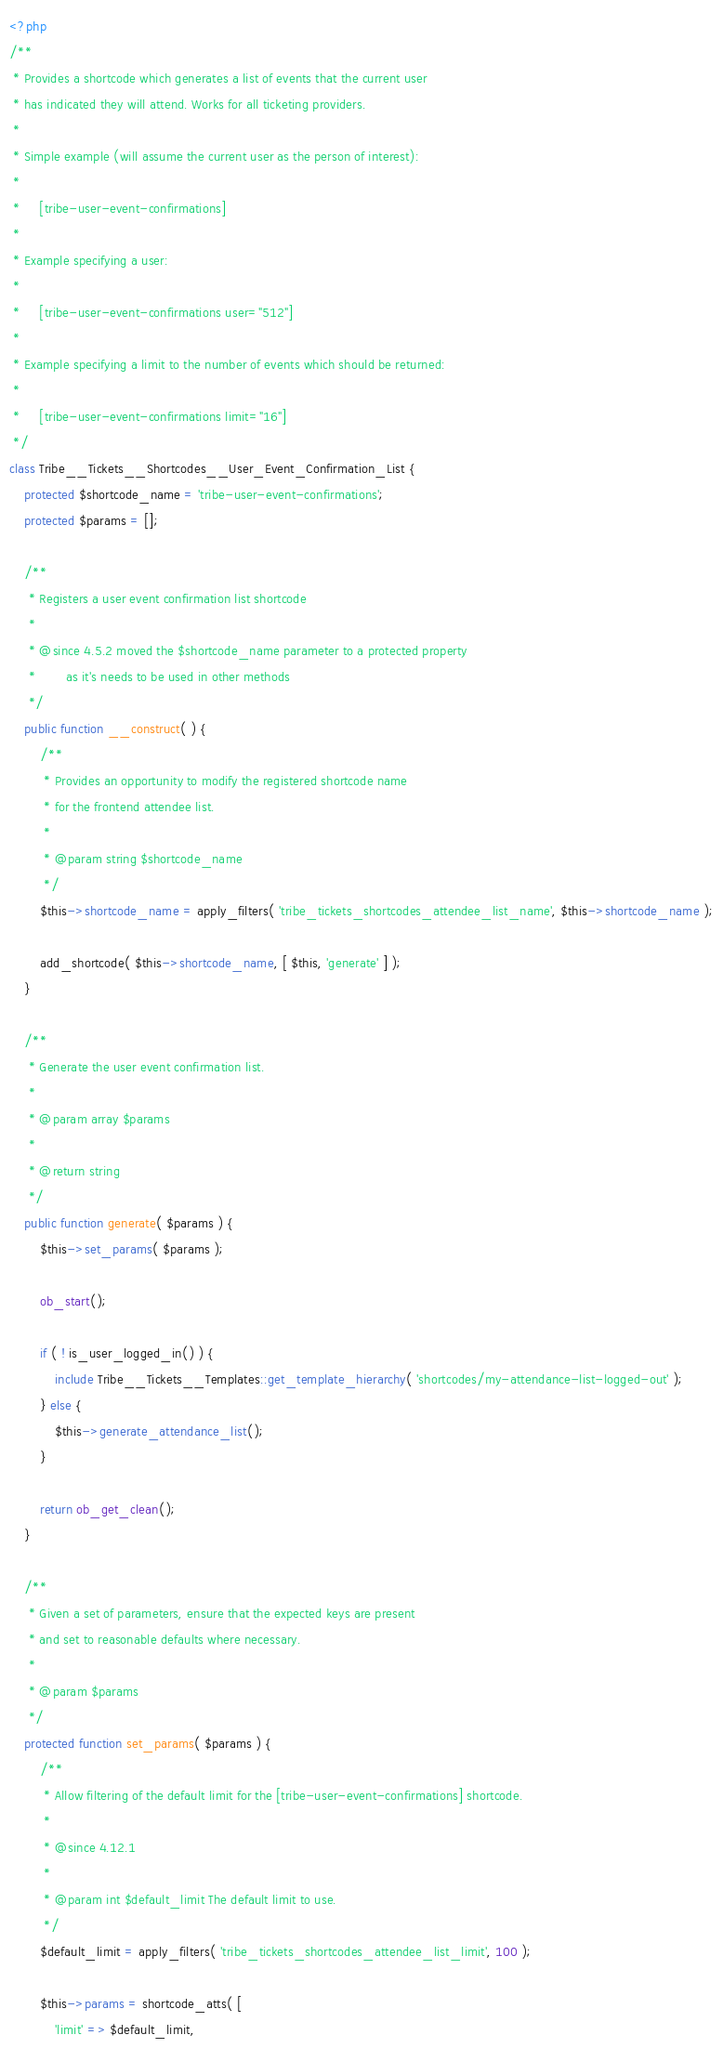Convert code to text. <code><loc_0><loc_0><loc_500><loc_500><_PHP_><?php
/**
 * Provides a shortcode which generates a list of events that the current user
 * has indicated they will attend. Works for all ticketing providers.
 *
 * Simple example (will assume the current user as the person of interest):
 *
 *     [tribe-user-event-confirmations]
 *
 * Example specifying a user:
 *
 *     [tribe-user-event-confirmations user="512"]
 *
 * Example specifying a limit to the number of events which should be returned:
 *
 *     [tribe-user-event-confirmations limit="16"]
 */
class Tribe__Tickets__Shortcodes__User_Event_Confirmation_List {
	protected $shortcode_name = 'tribe-user-event-confirmations';
	protected $params = [];

	/**
	 * Registers a user event confirmation list shortcode
	 *
	 * @since 4.5.2 moved the $shortcode_name parameter to a protected property
	 *        as it's needs to be used in other methods
	 */
	public function __construct( ) {
		/**
		 * Provides an opportunity to modify the registered shortcode name
		 * for the frontend attendee list.
		 *
		 * @param string $shortcode_name
		 */
		$this->shortcode_name = apply_filters( 'tribe_tickets_shortcodes_attendee_list_name', $this->shortcode_name );

		add_shortcode( $this->shortcode_name, [ $this, 'generate' ] );
	}

	/**
	 * Generate the user event confirmation list.
	 *
	 * @param array $params
	 *
	 * @return string
	 */
	public function generate( $params ) {
		$this->set_params( $params );

		ob_start();

		if ( ! is_user_logged_in() ) {
			include Tribe__Tickets__Templates::get_template_hierarchy( 'shortcodes/my-attendance-list-logged-out' );
		} else {
			$this->generate_attendance_list();
		}

		return ob_get_clean();
	}

	/**
	 * Given a set of parameters, ensure that the expected keys are present
	 * and set to reasonable defaults where necessary.
	 *
	 * @param $params
	 */
	protected function set_params( $params ) {
		/**
		 * Allow filtering of the default limit for the [tribe-user-event-confirmations] shortcode.
		 *
		 * @since 4.12.1
		 *
		 * @param int $default_limit The default limit to use.
		 */
		$default_limit = apply_filters( 'tribe_tickets_shortcodes_attendee_list_limit', 100 );

		$this->params = shortcode_atts( [
			'limit' => $default_limit,</code> 